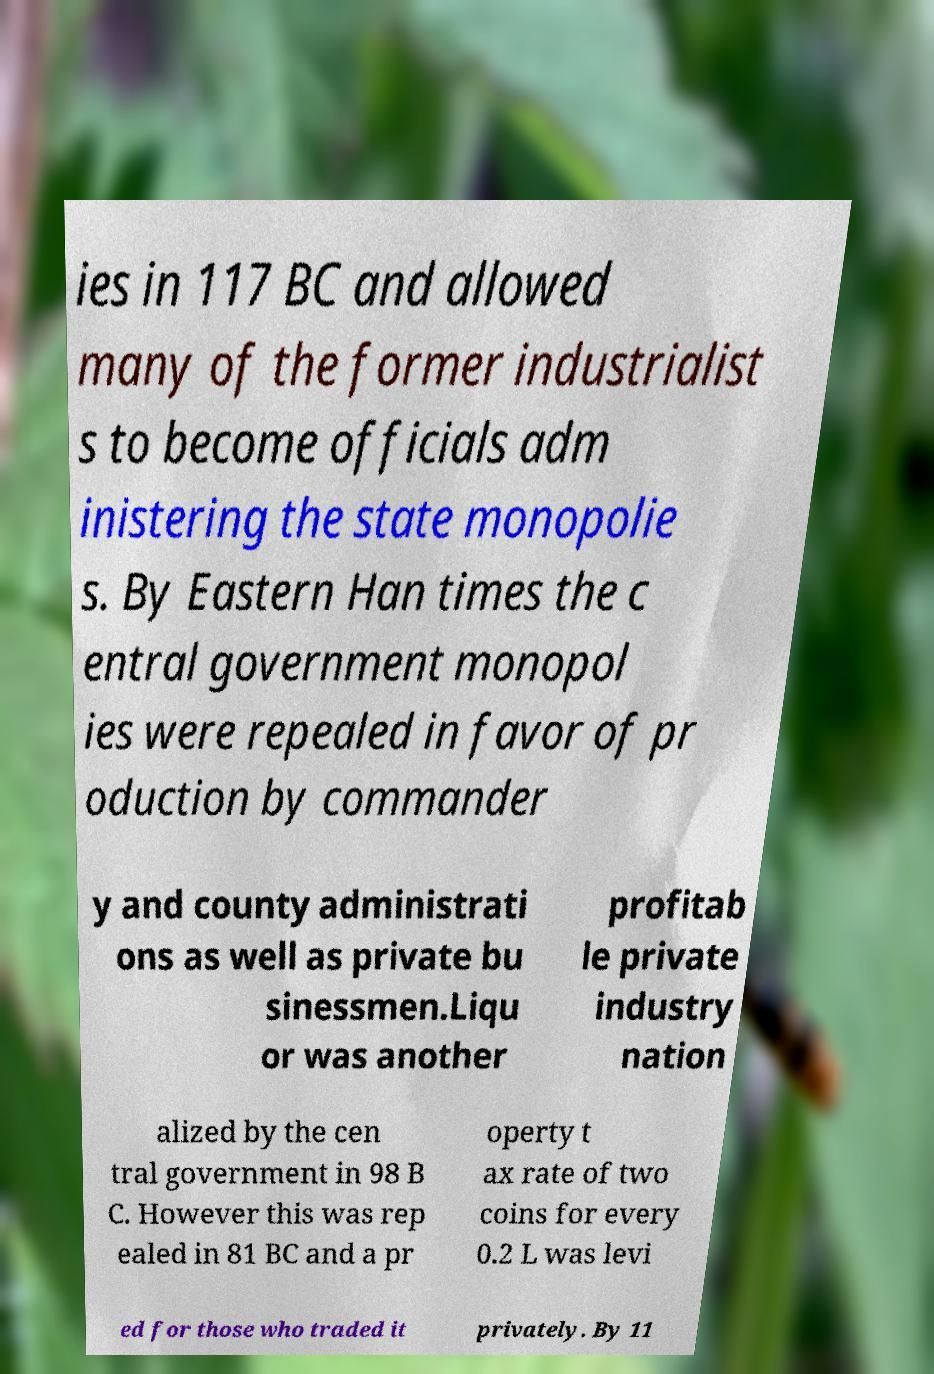There's text embedded in this image that I need extracted. Can you transcribe it verbatim? ies in 117 BC and allowed many of the former industrialist s to become officials adm inistering the state monopolie s. By Eastern Han times the c entral government monopol ies were repealed in favor of pr oduction by commander y and county administrati ons as well as private bu sinessmen.Liqu or was another profitab le private industry nation alized by the cen tral government in 98 B C. However this was rep ealed in 81 BC and a pr operty t ax rate of two coins for every 0.2 L was levi ed for those who traded it privately. By 11 